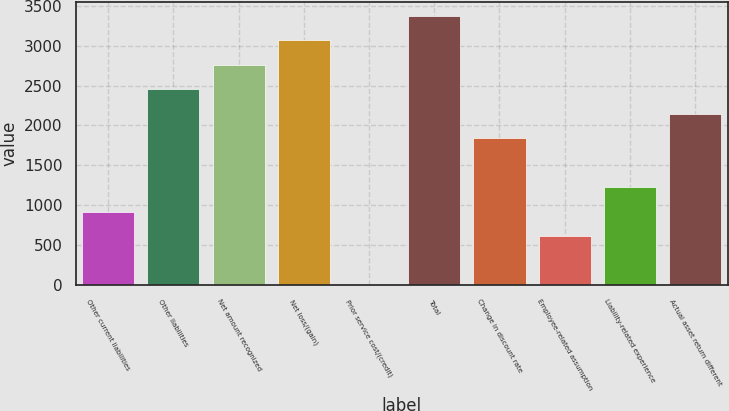Convert chart to OTSL. <chart><loc_0><loc_0><loc_500><loc_500><bar_chart><fcel>Other current liabilities<fcel>Other liabilities<fcel>Net amount recognized<fcel>Net loss/(gain)<fcel>Prior service cost/(credit)<fcel>Total<fcel>Change in discount rate<fcel>Employee-related assumption<fcel>Liability-related experience<fcel>Actual asset return different<nl><fcel>920.5<fcel>2453<fcel>2759.5<fcel>3066<fcel>1<fcel>3372.5<fcel>1840<fcel>614<fcel>1227<fcel>2146.5<nl></chart> 